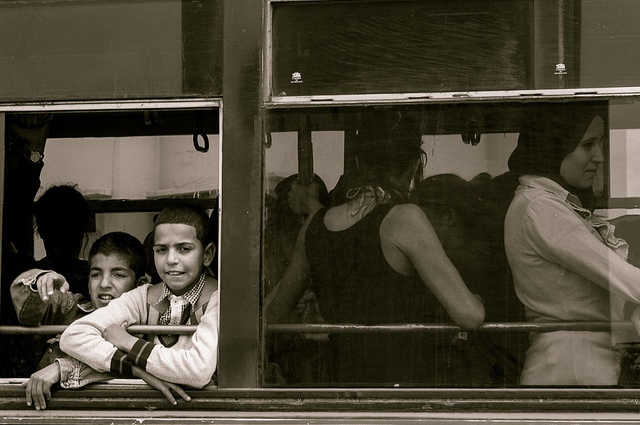Describe the objects in this image and their specific colors. I can see bus in black, gray, and darkgray tones, people in black and gray tones, people in black and gray tones, people in black, lightgray, darkgray, and gray tones, and people in black and gray tones in this image. 